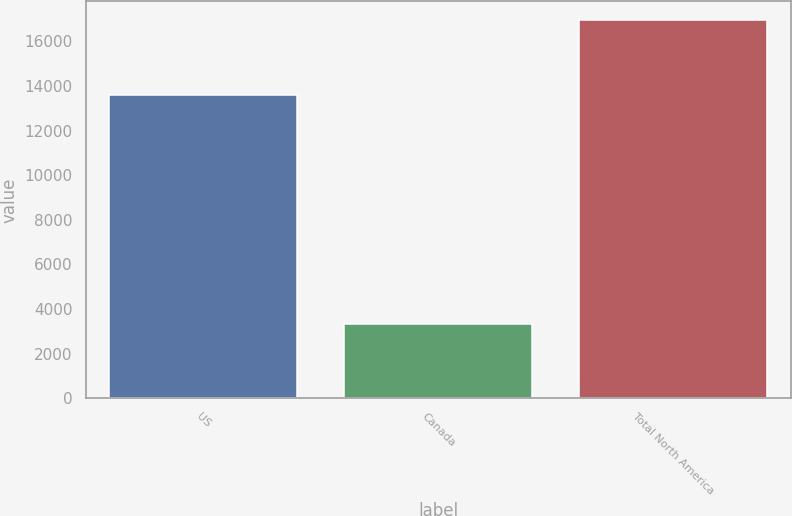<chart> <loc_0><loc_0><loc_500><loc_500><bar_chart><fcel>US<fcel>Canada<fcel>Total North America<nl><fcel>13613<fcel>3322<fcel>16935<nl></chart> 